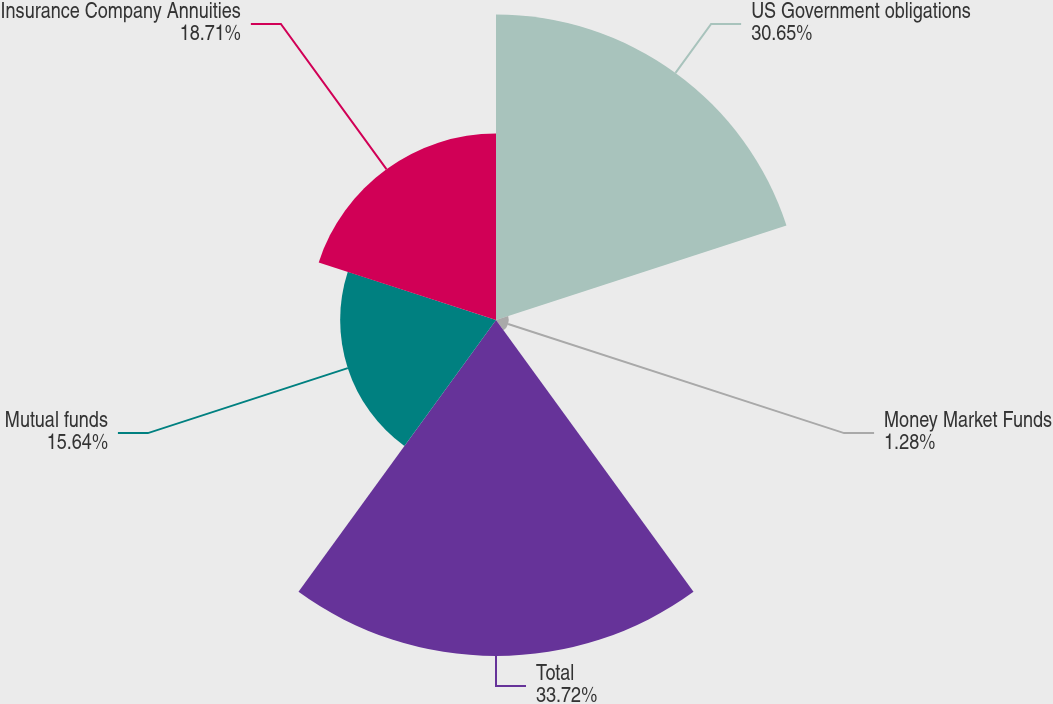Convert chart to OTSL. <chart><loc_0><loc_0><loc_500><loc_500><pie_chart><fcel>US Government obligations<fcel>Money Market Funds<fcel>Total<fcel>Mutual funds<fcel>Insurance Company Annuities<nl><fcel>30.65%<fcel>1.28%<fcel>33.72%<fcel>15.64%<fcel>18.71%<nl></chart> 